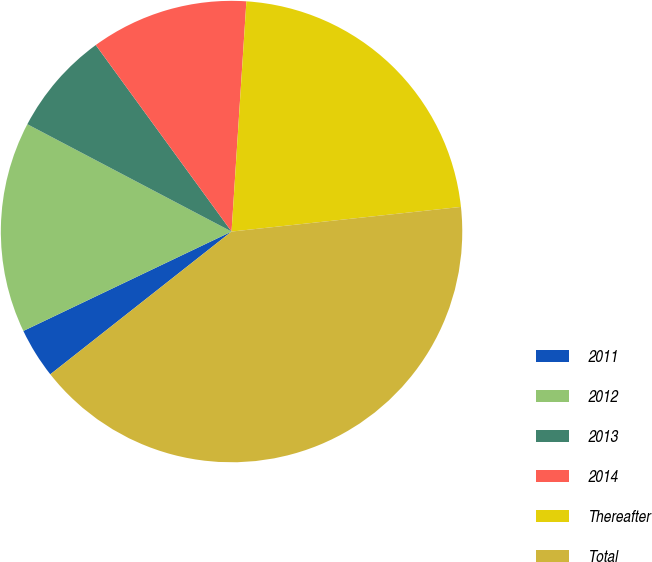Convert chart to OTSL. <chart><loc_0><loc_0><loc_500><loc_500><pie_chart><fcel>2011<fcel>2012<fcel>2013<fcel>2014<fcel>Thereafter<fcel>Total<nl><fcel>3.53%<fcel>14.79%<fcel>7.28%<fcel>11.04%<fcel>22.27%<fcel>41.08%<nl></chart> 